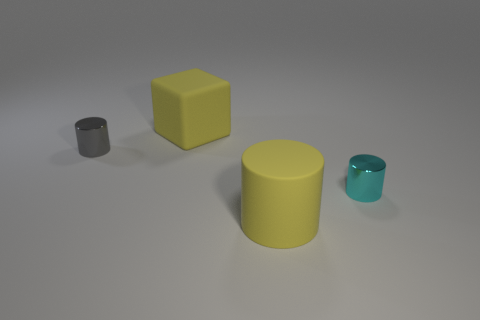Which objects in the image are cylinders? There are two cylinders in the image: one is gray and the other is a larger yellow one. 